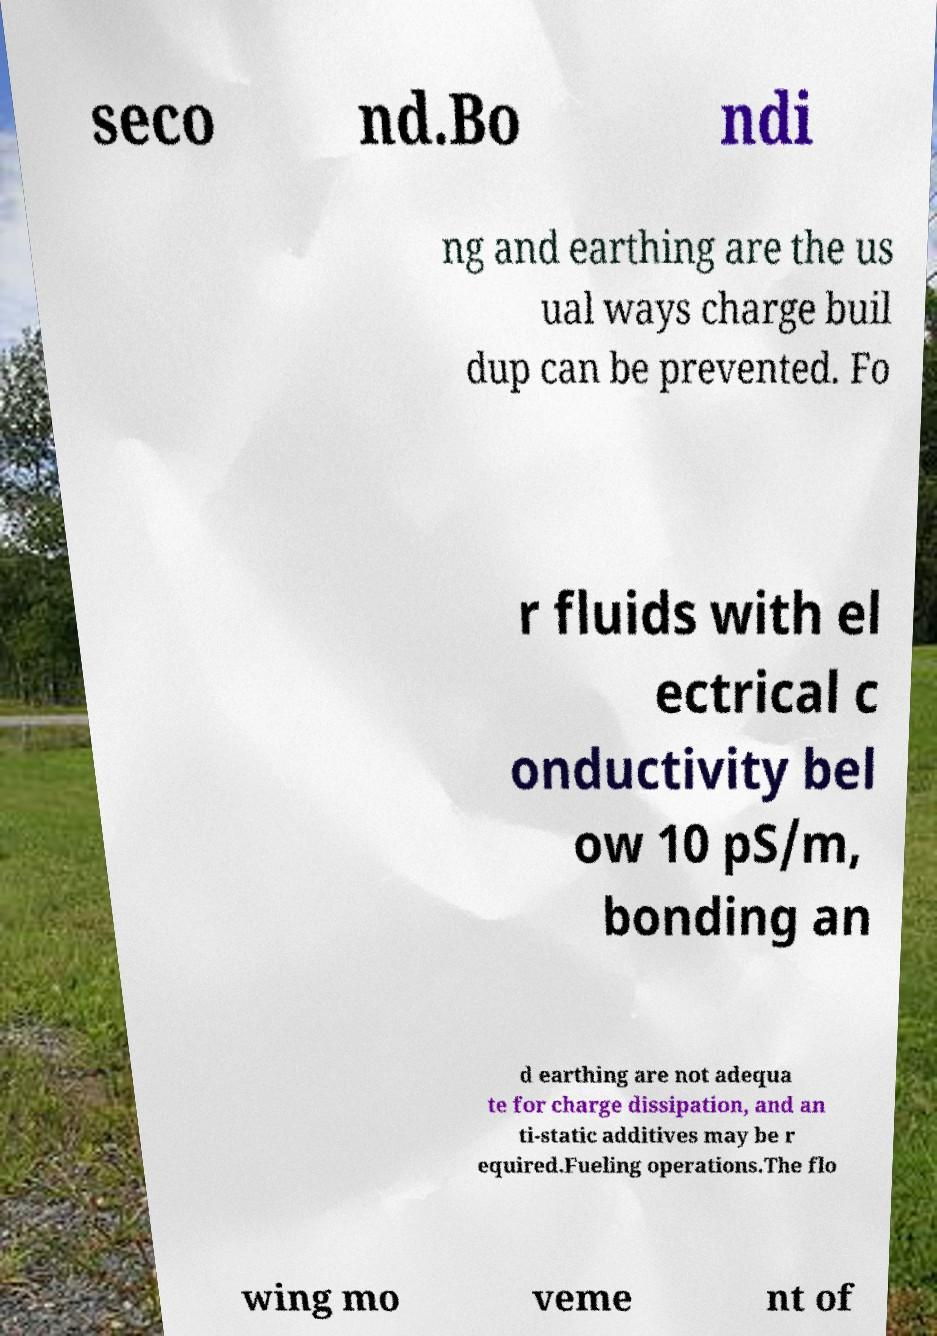Can you read and provide the text displayed in the image?This photo seems to have some interesting text. Can you extract and type it out for me? seco nd.Bo ndi ng and earthing are the us ual ways charge buil dup can be prevented. Fo r fluids with el ectrical c onductivity bel ow 10 pS/m, bonding an d earthing are not adequa te for charge dissipation, and an ti-static additives may be r equired.Fueling operations.The flo wing mo veme nt of 